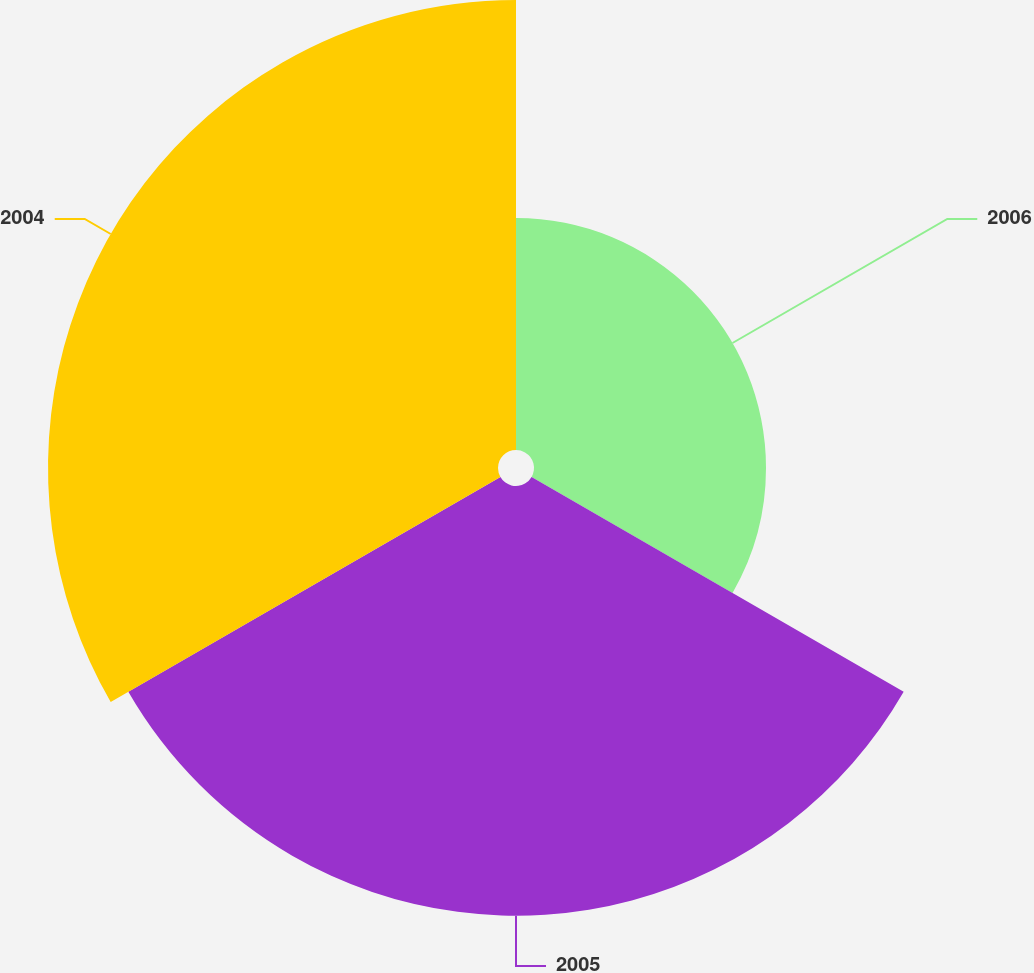Convert chart to OTSL. <chart><loc_0><loc_0><loc_500><loc_500><pie_chart><fcel>2006<fcel>2005<fcel>2004<nl><fcel>20.87%<fcel>38.65%<fcel>40.48%<nl></chart> 